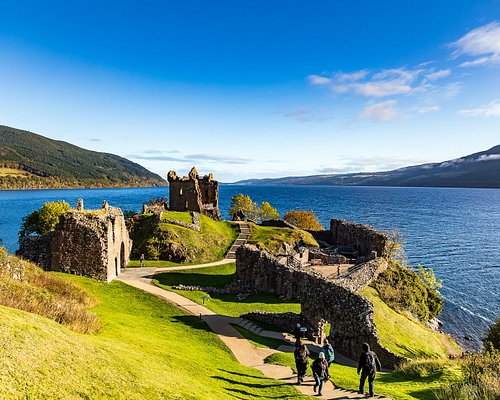Do you think the Loch Ness Monster could be real? Why or why not? The existence of the Loch Ness Monster, affectionately known as 'Nessie,' remains one of the world's most enduring mysteries. While there is no scientific evidence to support the existence of a large, unknown creature in the loch, the legend persists, fueled by numerous sightings and unexplained phenomena. The depth and murkiness of Loch Ness, along with its complex underwater geography, add an air of plausibility to the myth. Whether real or not, Nessie has certainly captured the imagination of people worldwide, adding an element of intrigue and magic to the already picturesque and historical landscape of Loch Ness. 